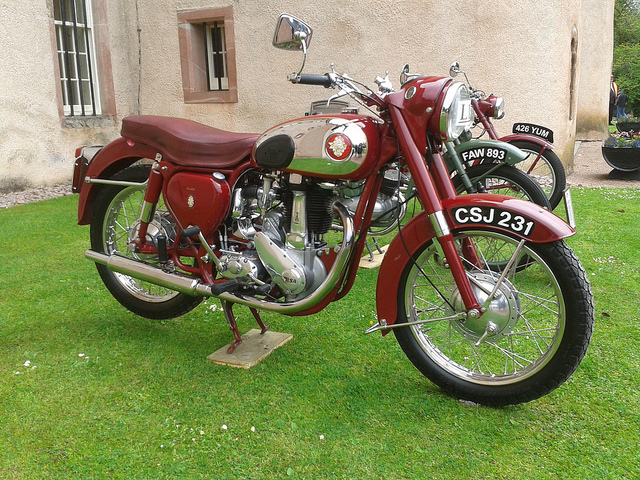Please transcribe the text information in this image. CSJ 231 FAW 893 426 YUM L 